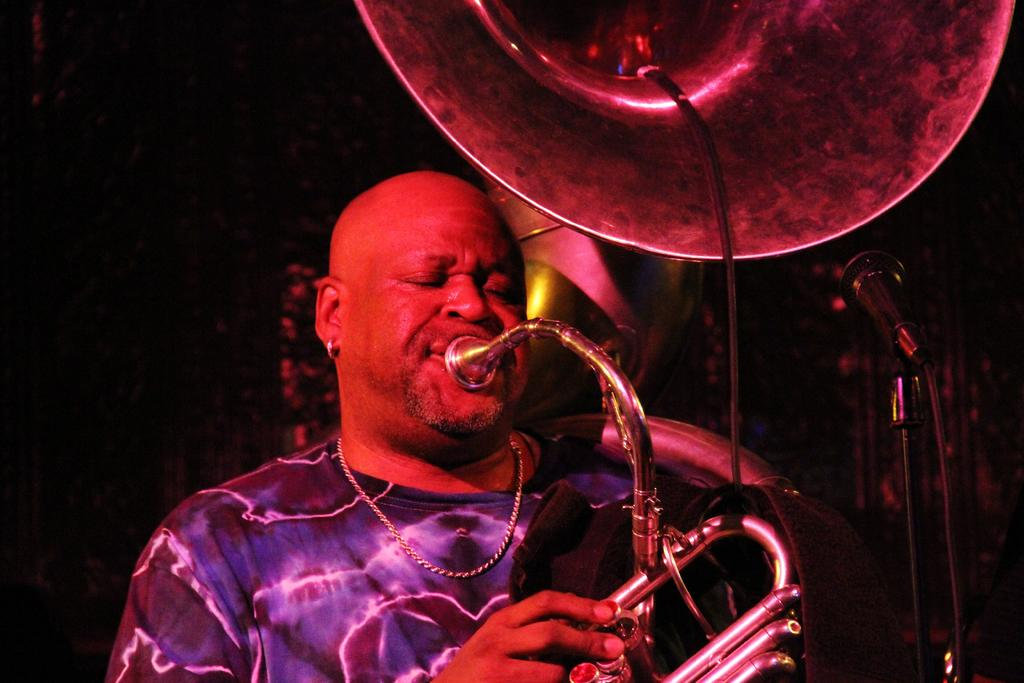Who is present in the image? There is a person in the image. What is the person wearing? The person is wearing a violet shirt. What is the person doing in the image? The person is playing a tuba. What can be seen on the right side of the image? There is a microphone stand on the right side of the image. What type of kite is the person flying in the image? There is no kite present in the image; the person is playing a tuba. What kind of cloth is draped over the tuba in the image? There is no cloth draped over the tuba in the image; the tuba is being played by the person. 